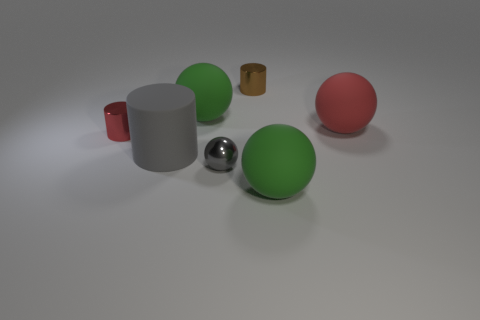Are there any patterns or repetitions in this composition? Indeed, there's a subtle repetition of shapes occurring in the composition. The spherical forms are repeated thrice - with the metallic gray, red, and one of the green objects, creating a visual rhythm. The cylindrical shapes also repeat, with one large gray and one miniaturized brown version, hinting at a play on scale and perspective within the image. 